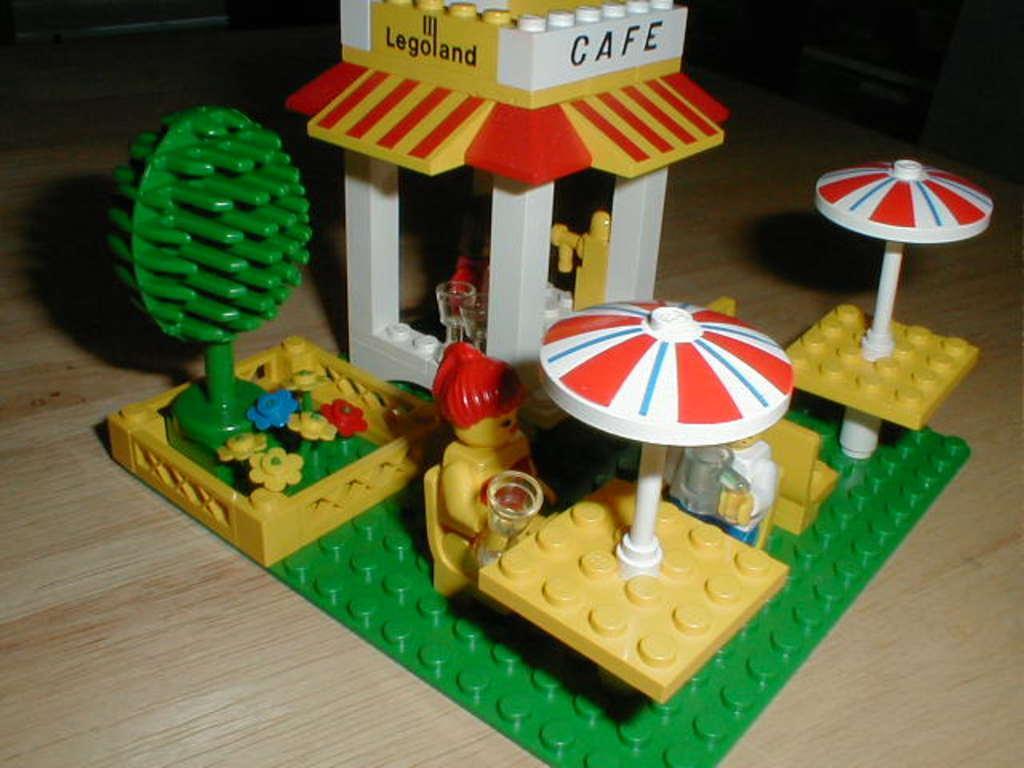In one or two sentences, can you explain what this image depicts? Here in this picture we can see Lego toys present on the table over there. 